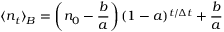Convert formula to latex. <formula><loc_0><loc_0><loc_500><loc_500>\langle n _ { t } \rangle _ { B } = \left ( n _ { 0 } - \frac { b } { a } \right ) ( 1 - a ) ^ { t / \Delta t } + \frac { b } { a }</formula> 